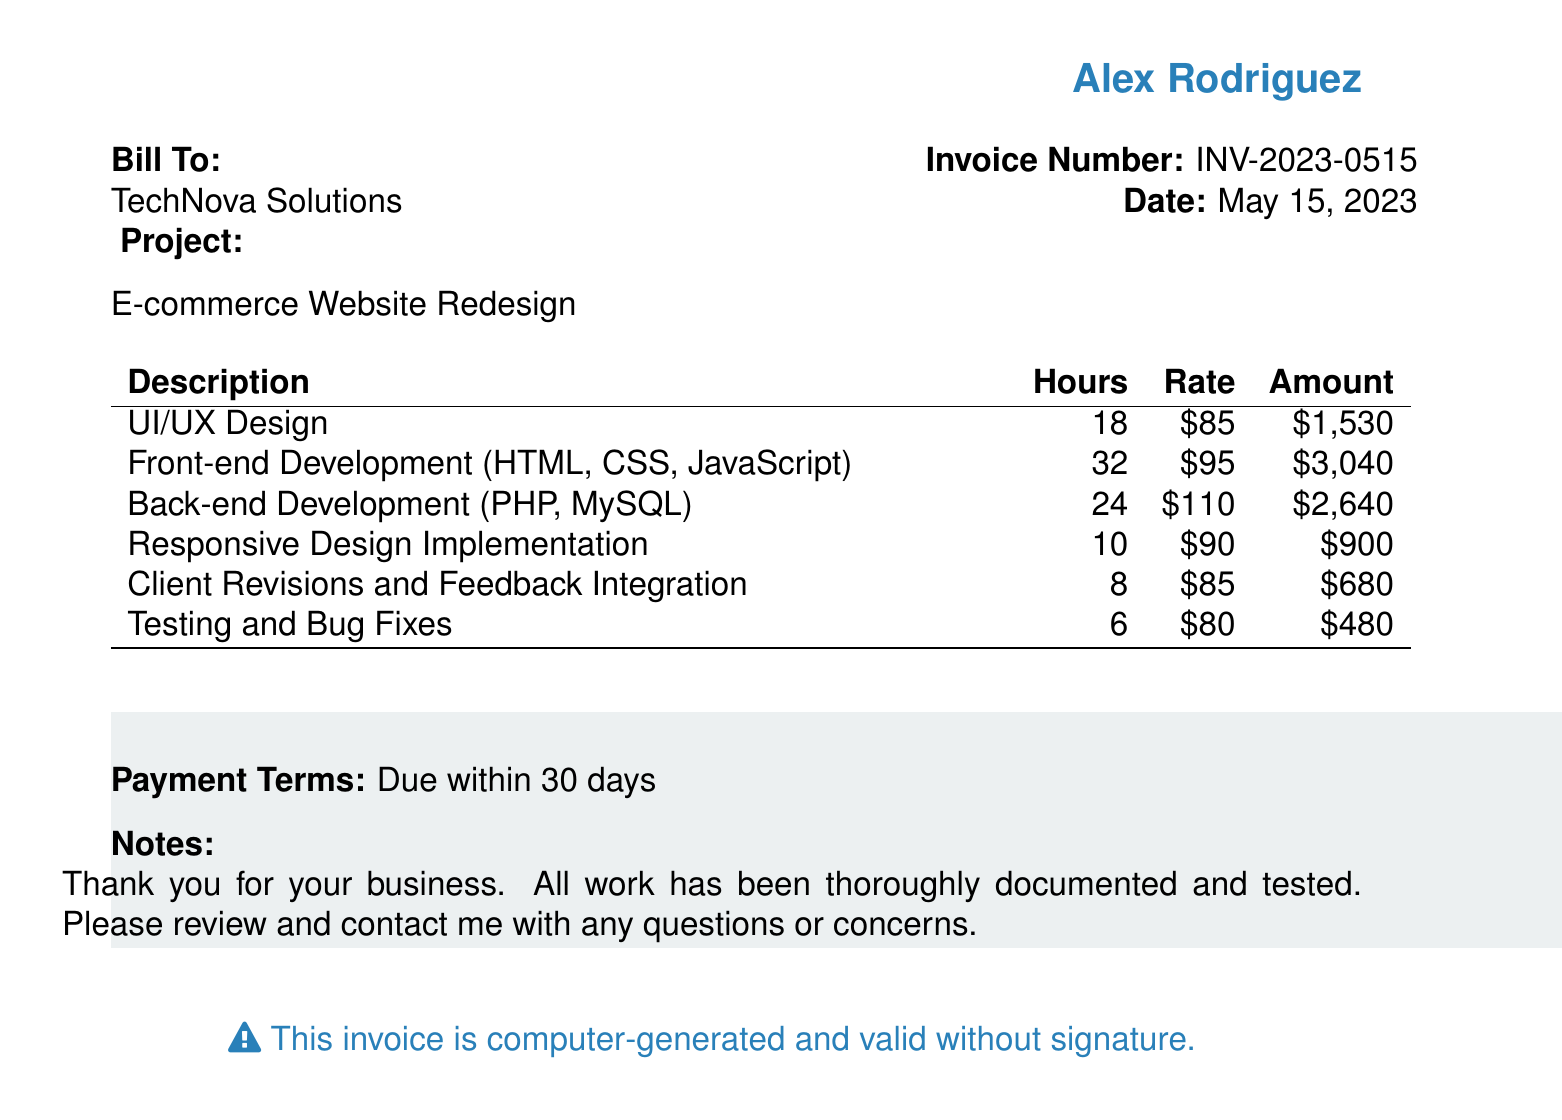What is the invoice number? The invoice number is specified in the document for identification purposes.
Answer: INV-2023-0515 What is the date of the invoice? The invoice date is clearly indicated, serving as the billing date.
Answer: May 15, 2023 How many hours were spent on UI/UX design? The document specifies the number of hours worked on each task.
Answer: 18 What is the total amount before tax? The subtotal is the total amount before any applicable tax is added.
Answer: $9,270.00 What percentage is the tax applied? The tax percentage is explicitly mentioned in the breakdown of costs.
Answer: 8% How much was charged for front-end development? The amount for front-end development is included in the detailed breakdown section.
Answer: $3,040 What type of project is this invoice associated with? The project type is mentioned under the 'Project' section addressing the client.
Answer: E-commerce Website Redesign What are the payment terms? The payment terms state the conditions under which payment is expected.
Answer: Due within 30 days What is included in the notes section? The notes section offers additional information or appreciation related to the service.
Answer: Thank you for your business. All work has been thoroughly documented and tested. Please review and contact me with any questions or concerns 